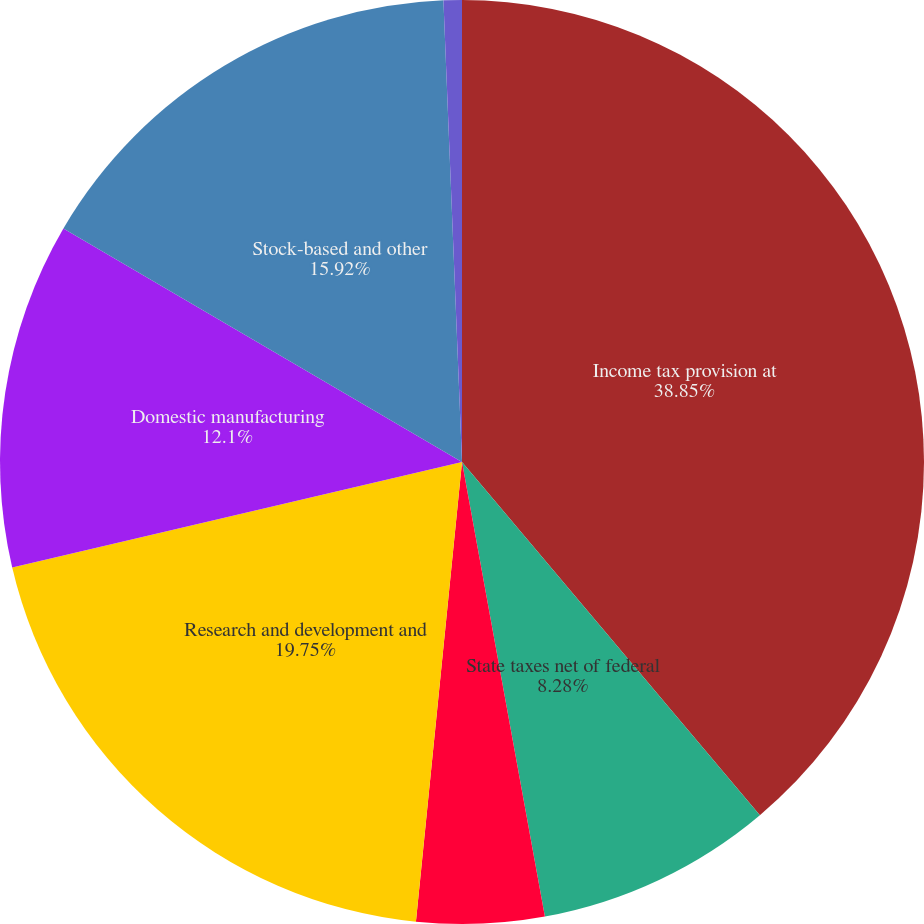Convert chart to OTSL. <chart><loc_0><loc_0><loc_500><loc_500><pie_chart><fcel>Income tax provision at<fcel>State taxes net of federal<fcel>Foreign operations<fcel>Research and development and<fcel>Domestic manufacturing<fcel>Stock-based and other<fcel>Other<nl><fcel>38.84%<fcel>8.28%<fcel>4.46%<fcel>19.74%<fcel>12.1%<fcel>15.92%<fcel>0.64%<nl></chart> 